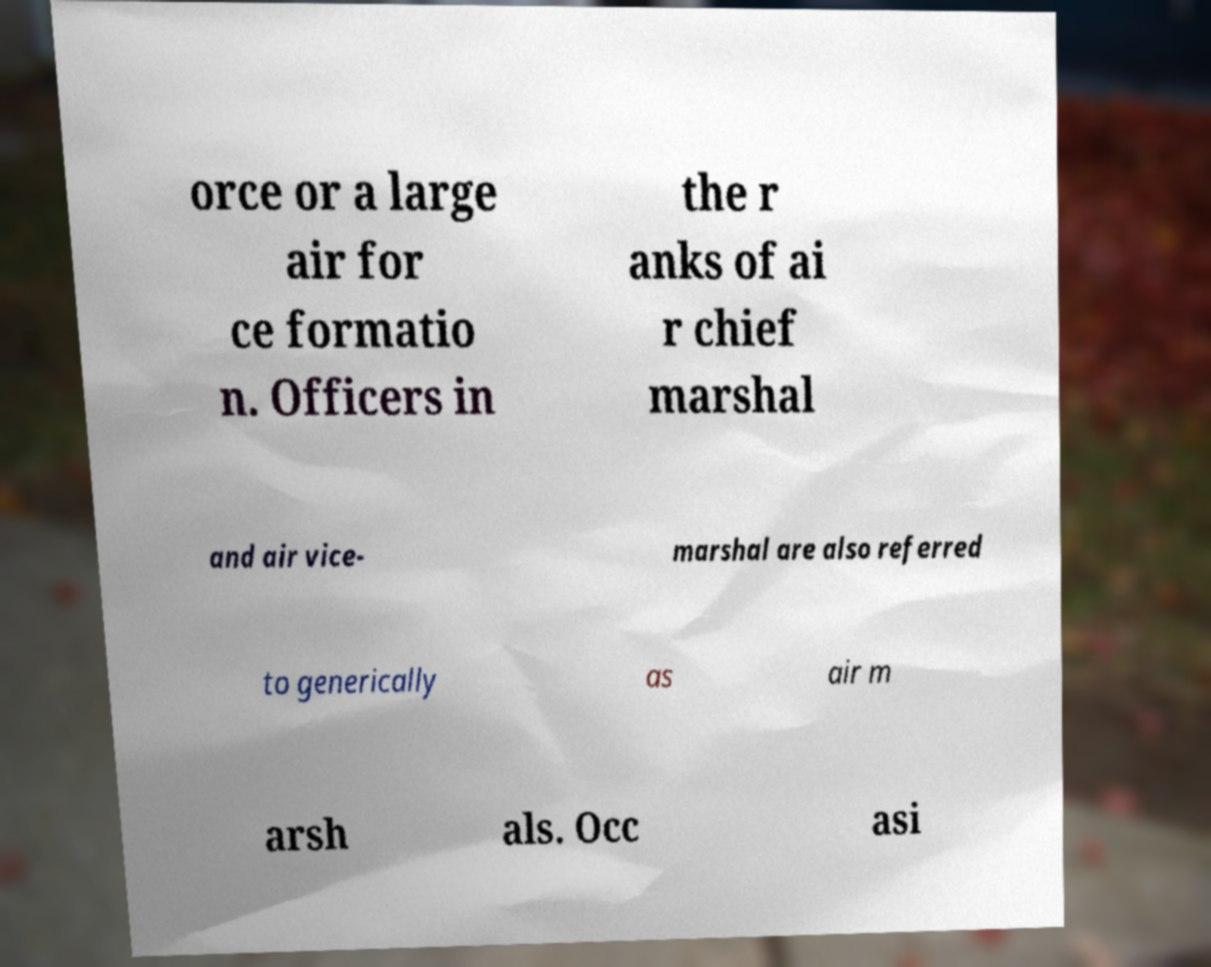Could you assist in decoding the text presented in this image and type it out clearly? orce or a large air for ce formatio n. Officers in the r anks of ai r chief marshal and air vice- marshal are also referred to generically as air m arsh als. Occ asi 